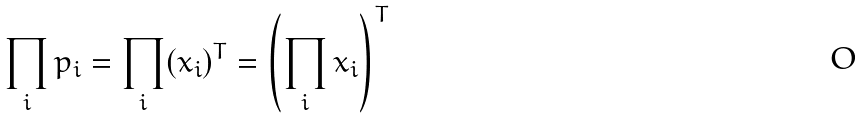Convert formula to latex. <formula><loc_0><loc_0><loc_500><loc_500>\prod _ { i } p _ { i } = \prod _ { i } ( x _ { i } ) ^ { T } = \left ( \prod _ { i } x _ { i } \right ) ^ { T }</formula> 